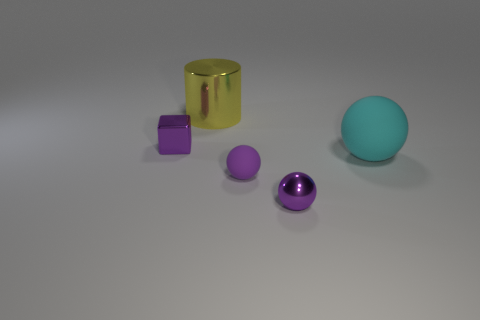Is the size of the metal cylinder the same as the shiny sphere?
Provide a short and direct response. No. Is the number of big cyan spheres in front of the cyan object less than the number of purple shiny blocks right of the tiny rubber ball?
Make the answer very short. No. Is there any other thing that is the same size as the purple shiny block?
Your response must be concise. Yes. What is the size of the cyan object?
Your answer should be very brief. Large. What number of big objects are either purple matte balls or purple spheres?
Ensure brevity in your answer.  0. There is a block; does it have the same size as the shiny thing to the right of the large cylinder?
Your answer should be compact. Yes. Is there anything else that is the same shape as the large rubber thing?
Your answer should be compact. Yes. How many metal objects are there?
Make the answer very short. 3. How many gray objects are either cylinders or tiny matte objects?
Your answer should be very brief. 0. Do the large thing that is behind the big matte thing and the cyan ball have the same material?
Provide a short and direct response. No. 